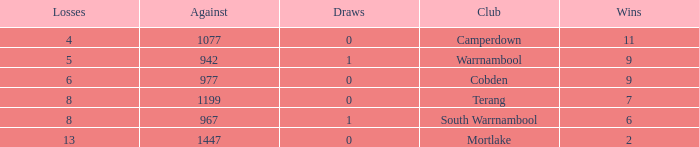What is the draw when the losses were more than 8 and less than 2 wins? None. 